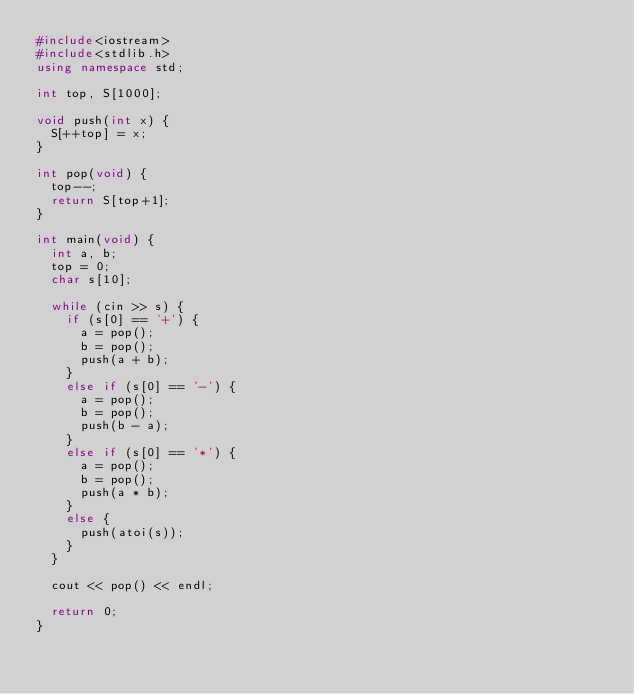<code> <loc_0><loc_0><loc_500><loc_500><_C++_>#include<iostream>
#include<stdlib.h>
using namespace std;

int top, S[1000];

void push(int x) {
	S[++top] = x;
}

int pop(void) {
	top--;
	return S[top+1];
}

int main(void) {
	int a, b;
	top = 0;
	char s[10];

	while (cin >> s) {
		if (s[0] == '+') {
			a = pop();
			b = pop();
			push(a + b);
		}
		else if (s[0] == '-') {
			a = pop();
			b = pop();
			push(b - a);
		}
		else if (s[0] == '*') {
			a = pop();
			b = pop();
			push(a * b);
		}
		else {
			push(atoi(s));
		}
	}
	
	cout << pop() << endl;

	return 0;
}</code> 